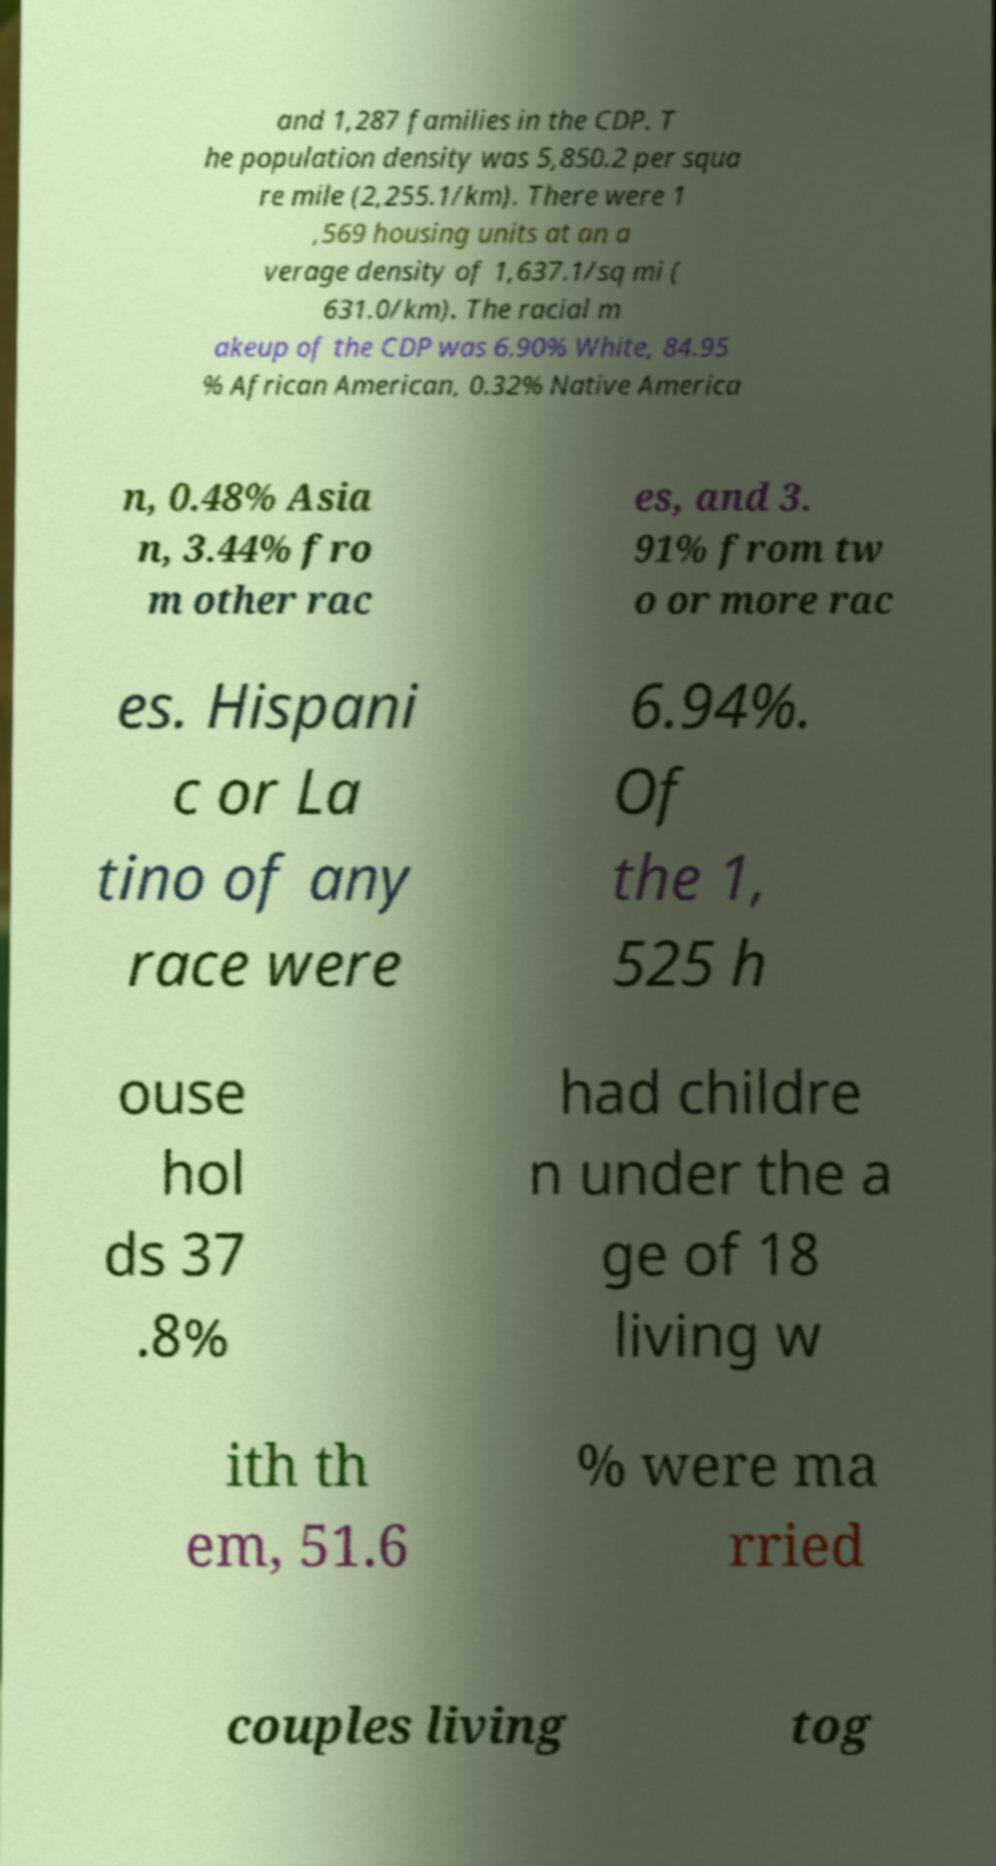Can you read and provide the text displayed in the image?This photo seems to have some interesting text. Can you extract and type it out for me? and 1,287 families in the CDP. T he population density was 5,850.2 per squa re mile (2,255.1/km). There were 1 ,569 housing units at an a verage density of 1,637.1/sq mi ( 631.0/km). The racial m akeup of the CDP was 6.90% White, 84.95 % African American, 0.32% Native America n, 0.48% Asia n, 3.44% fro m other rac es, and 3. 91% from tw o or more rac es. Hispani c or La tino of any race were 6.94%. Of the 1, 525 h ouse hol ds 37 .8% had childre n under the a ge of 18 living w ith th em, 51.6 % were ma rried couples living tog 